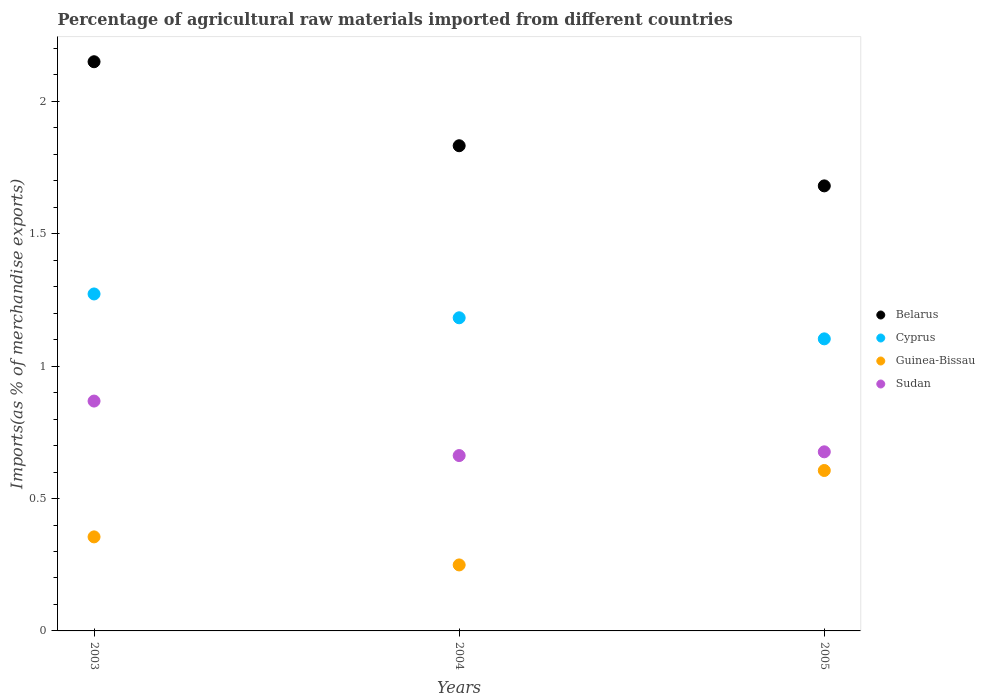Is the number of dotlines equal to the number of legend labels?
Offer a very short reply. Yes. What is the percentage of imports to different countries in Belarus in 2005?
Keep it short and to the point. 1.68. Across all years, what is the maximum percentage of imports to different countries in Sudan?
Offer a very short reply. 0.87. Across all years, what is the minimum percentage of imports to different countries in Sudan?
Your answer should be very brief. 0.66. What is the total percentage of imports to different countries in Belarus in the graph?
Offer a terse response. 5.66. What is the difference between the percentage of imports to different countries in Cyprus in 2003 and that in 2004?
Provide a succinct answer. 0.09. What is the difference between the percentage of imports to different countries in Sudan in 2003 and the percentage of imports to different countries in Guinea-Bissau in 2005?
Ensure brevity in your answer.  0.26. What is the average percentage of imports to different countries in Guinea-Bissau per year?
Give a very brief answer. 0.4. In the year 2004, what is the difference between the percentage of imports to different countries in Belarus and percentage of imports to different countries in Cyprus?
Offer a very short reply. 0.65. In how many years, is the percentage of imports to different countries in Cyprus greater than 0.1 %?
Give a very brief answer. 3. What is the ratio of the percentage of imports to different countries in Sudan in 2004 to that in 2005?
Your answer should be very brief. 0.98. What is the difference between the highest and the second highest percentage of imports to different countries in Guinea-Bissau?
Your answer should be very brief. 0.25. What is the difference between the highest and the lowest percentage of imports to different countries in Cyprus?
Provide a short and direct response. 0.17. In how many years, is the percentage of imports to different countries in Cyprus greater than the average percentage of imports to different countries in Cyprus taken over all years?
Make the answer very short. 1. Is the sum of the percentage of imports to different countries in Sudan in 2003 and 2004 greater than the maximum percentage of imports to different countries in Guinea-Bissau across all years?
Your response must be concise. Yes. Does the percentage of imports to different countries in Sudan monotonically increase over the years?
Offer a terse response. No. How many dotlines are there?
Offer a very short reply. 4. Does the graph contain any zero values?
Give a very brief answer. No. How many legend labels are there?
Give a very brief answer. 4. How are the legend labels stacked?
Offer a very short reply. Vertical. What is the title of the graph?
Offer a very short reply. Percentage of agricultural raw materials imported from different countries. Does "Czech Republic" appear as one of the legend labels in the graph?
Offer a terse response. No. What is the label or title of the X-axis?
Give a very brief answer. Years. What is the label or title of the Y-axis?
Offer a very short reply. Imports(as % of merchandise exports). What is the Imports(as % of merchandise exports) of Belarus in 2003?
Make the answer very short. 2.15. What is the Imports(as % of merchandise exports) of Cyprus in 2003?
Provide a short and direct response. 1.27. What is the Imports(as % of merchandise exports) of Guinea-Bissau in 2003?
Give a very brief answer. 0.36. What is the Imports(as % of merchandise exports) in Sudan in 2003?
Offer a terse response. 0.87. What is the Imports(as % of merchandise exports) in Belarus in 2004?
Give a very brief answer. 1.83. What is the Imports(as % of merchandise exports) in Cyprus in 2004?
Provide a short and direct response. 1.18. What is the Imports(as % of merchandise exports) in Guinea-Bissau in 2004?
Provide a succinct answer. 0.25. What is the Imports(as % of merchandise exports) of Sudan in 2004?
Ensure brevity in your answer.  0.66. What is the Imports(as % of merchandise exports) of Belarus in 2005?
Your response must be concise. 1.68. What is the Imports(as % of merchandise exports) of Cyprus in 2005?
Provide a short and direct response. 1.1. What is the Imports(as % of merchandise exports) in Guinea-Bissau in 2005?
Offer a very short reply. 0.61. What is the Imports(as % of merchandise exports) of Sudan in 2005?
Offer a very short reply. 0.68. Across all years, what is the maximum Imports(as % of merchandise exports) of Belarus?
Provide a short and direct response. 2.15. Across all years, what is the maximum Imports(as % of merchandise exports) in Cyprus?
Your answer should be very brief. 1.27. Across all years, what is the maximum Imports(as % of merchandise exports) in Guinea-Bissau?
Keep it short and to the point. 0.61. Across all years, what is the maximum Imports(as % of merchandise exports) in Sudan?
Provide a short and direct response. 0.87. Across all years, what is the minimum Imports(as % of merchandise exports) in Belarus?
Keep it short and to the point. 1.68. Across all years, what is the minimum Imports(as % of merchandise exports) of Cyprus?
Make the answer very short. 1.1. Across all years, what is the minimum Imports(as % of merchandise exports) in Guinea-Bissau?
Ensure brevity in your answer.  0.25. Across all years, what is the minimum Imports(as % of merchandise exports) of Sudan?
Your response must be concise. 0.66. What is the total Imports(as % of merchandise exports) of Belarus in the graph?
Make the answer very short. 5.66. What is the total Imports(as % of merchandise exports) of Cyprus in the graph?
Keep it short and to the point. 3.56. What is the total Imports(as % of merchandise exports) in Guinea-Bissau in the graph?
Provide a succinct answer. 1.21. What is the total Imports(as % of merchandise exports) of Sudan in the graph?
Your answer should be very brief. 2.21. What is the difference between the Imports(as % of merchandise exports) of Belarus in 2003 and that in 2004?
Give a very brief answer. 0.32. What is the difference between the Imports(as % of merchandise exports) in Cyprus in 2003 and that in 2004?
Offer a terse response. 0.09. What is the difference between the Imports(as % of merchandise exports) in Guinea-Bissau in 2003 and that in 2004?
Your answer should be compact. 0.11. What is the difference between the Imports(as % of merchandise exports) of Sudan in 2003 and that in 2004?
Provide a short and direct response. 0.21. What is the difference between the Imports(as % of merchandise exports) of Belarus in 2003 and that in 2005?
Your answer should be very brief. 0.47. What is the difference between the Imports(as % of merchandise exports) in Cyprus in 2003 and that in 2005?
Offer a very short reply. 0.17. What is the difference between the Imports(as % of merchandise exports) of Guinea-Bissau in 2003 and that in 2005?
Offer a terse response. -0.25. What is the difference between the Imports(as % of merchandise exports) of Sudan in 2003 and that in 2005?
Make the answer very short. 0.19. What is the difference between the Imports(as % of merchandise exports) of Belarus in 2004 and that in 2005?
Your response must be concise. 0.15. What is the difference between the Imports(as % of merchandise exports) of Cyprus in 2004 and that in 2005?
Make the answer very short. 0.08. What is the difference between the Imports(as % of merchandise exports) of Guinea-Bissau in 2004 and that in 2005?
Your answer should be compact. -0.36. What is the difference between the Imports(as % of merchandise exports) in Sudan in 2004 and that in 2005?
Ensure brevity in your answer.  -0.01. What is the difference between the Imports(as % of merchandise exports) in Belarus in 2003 and the Imports(as % of merchandise exports) in Cyprus in 2004?
Ensure brevity in your answer.  0.97. What is the difference between the Imports(as % of merchandise exports) of Belarus in 2003 and the Imports(as % of merchandise exports) of Guinea-Bissau in 2004?
Make the answer very short. 1.9. What is the difference between the Imports(as % of merchandise exports) of Belarus in 2003 and the Imports(as % of merchandise exports) of Sudan in 2004?
Keep it short and to the point. 1.49. What is the difference between the Imports(as % of merchandise exports) of Cyprus in 2003 and the Imports(as % of merchandise exports) of Guinea-Bissau in 2004?
Offer a terse response. 1.02. What is the difference between the Imports(as % of merchandise exports) of Cyprus in 2003 and the Imports(as % of merchandise exports) of Sudan in 2004?
Ensure brevity in your answer.  0.61. What is the difference between the Imports(as % of merchandise exports) in Guinea-Bissau in 2003 and the Imports(as % of merchandise exports) in Sudan in 2004?
Make the answer very short. -0.31. What is the difference between the Imports(as % of merchandise exports) in Belarus in 2003 and the Imports(as % of merchandise exports) in Cyprus in 2005?
Your answer should be compact. 1.05. What is the difference between the Imports(as % of merchandise exports) in Belarus in 2003 and the Imports(as % of merchandise exports) in Guinea-Bissau in 2005?
Give a very brief answer. 1.54. What is the difference between the Imports(as % of merchandise exports) of Belarus in 2003 and the Imports(as % of merchandise exports) of Sudan in 2005?
Give a very brief answer. 1.47. What is the difference between the Imports(as % of merchandise exports) of Cyprus in 2003 and the Imports(as % of merchandise exports) of Guinea-Bissau in 2005?
Provide a short and direct response. 0.67. What is the difference between the Imports(as % of merchandise exports) of Cyprus in 2003 and the Imports(as % of merchandise exports) of Sudan in 2005?
Offer a very short reply. 0.6. What is the difference between the Imports(as % of merchandise exports) of Guinea-Bissau in 2003 and the Imports(as % of merchandise exports) of Sudan in 2005?
Offer a very short reply. -0.32. What is the difference between the Imports(as % of merchandise exports) of Belarus in 2004 and the Imports(as % of merchandise exports) of Cyprus in 2005?
Make the answer very short. 0.73. What is the difference between the Imports(as % of merchandise exports) in Belarus in 2004 and the Imports(as % of merchandise exports) in Guinea-Bissau in 2005?
Your answer should be very brief. 1.23. What is the difference between the Imports(as % of merchandise exports) of Belarus in 2004 and the Imports(as % of merchandise exports) of Sudan in 2005?
Ensure brevity in your answer.  1.16. What is the difference between the Imports(as % of merchandise exports) in Cyprus in 2004 and the Imports(as % of merchandise exports) in Guinea-Bissau in 2005?
Your answer should be very brief. 0.58. What is the difference between the Imports(as % of merchandise exports) in Cyprus in 2004 and the Imports(as % of merchandise exports) in Sudan in 2005?
Your answer should be very brief. 0.51. What is the difference between the Imports(as % of merchandise exports) in Guinea-Bissau in 2004 and the Imports(as % of merchandise exports) in Sudan in 2005?
Offer a terse response. -0.43. What is the average Imports(as % of merchandise exports) of Belarus per year?
Ensure brevity in your answer.  1.89. What is the average Imports(as % of merchandise exports) in Cyprus per year?
Your answer should be very brief. 1.19. What is the average Imports(as % of merchandise exports) of Guinea-Bissau per year?
Offer a terse response. 0.4. What is the average Imports(as % of merchandise exports) in Sudan per year?
Keep it short and to the point. 0.74. In the year 2003, what is the difference between the Imports(as % of merchandise exports) in Belarus and Imports(as % of merchandise exports) in Cyprus?
Offer a terse response. 0.88. In the year 2003, what is the difference between the Imports(as % of merchandise exports) in Belarus and Imports(as % of merchandise exports) in Guinea-Bissau?
Provide a succinct answer. 1.79. In the year 2003, what is the difference between the Imports(as % of merchandise exports) of Belarus and Imports(as % of merchandise exports) of Sudan?
Provide a succinct answer. 1.28. In the year 2003, what is the difference between the Imports(as % of merchandise exports) in Cyprus and Imports(as % of merchandise exports) in Guinea-Bissau?
Keep it short and to the point. 0.92. In the year 2003, what is the difference between the Imports(as % of merchandise exports) in Cyprus and Imports(as % of merchandise exports) in Sudan?
Give a very brief answer. 0.4. In the year 2003, what is the difference between the Imports(as % of merchandise exports) in Guinea-Bissau and Imports(as % of merchandise exports) in Sudan?
Provide a succinct answer. -0.51. In the year 2004, what is the difference between the Imports(as % of merchandise exports) of Belarus and Imports(as % of merchandise exports) of Cyprus?
Ensure brevity in your answer.  0.65. In the year 2004, what is the difference between the Imports(as % of merchandise exports) of Belarus and Imports(as % of merchandise exports) of Guinea-Bissau?
Offer a very short reply. 1.58. In the year 2004, what is the difference between the Imports(as % of merchandise exports) of Belarus and Imports(as % of merchandise exports) of Sudan?
Your answer should be compact. 1.17. In the year 2004, what is the difference between the Imports(as % of merchandise exports) in Cyprus and Imports(as % of merchandise exports) in Guinea-Bissau?
Your answer should be compact. 0.93. In the year 2004, what is the difference between the Imports(as % of merchandise exports) of Cyprus and Imports(as % of merchandise exports) of Sudan?
Offer a very short reply. 0.52. In the year 2004, what is the difference between the Imports(as % of merchandise exports) of Guinea-Bissau and Imports(as % of merchandise exports) of Sudan?
Keep it short and to the point. -0.41. In the year 2005, what is the difference between the Imports(as % of merchandise exports) in Belarus and Imports(as % of merchandise exports) in Cyprus?
Your response must be concise. 0.58. In the year 2005, what is the difference between the Imports(as % of merchandise exports) of Belarus and Imports(as % of merchandise exports) of Guinea-Bissau?
Offer a terse response. 1.07. In the year 2005, what is the difference between the Imports(as % of merchandise exports) in Belarus and Imports(as % of merchandise exports) in Sudan?
Your answer should be compact. 1. In the year 2005, what is the difference between the Imports(as % of merchandise exports) in Cyprus and Imports(as % of merchandise exports) in Guinea-Bissau?
Give a very brief answer. 0.5. In the year 2005, what is the difference between the Imports(as % of merchandise exports) in Cyprus and Imports(as % of merchandise exports) in Sudan?
Provide a succinct answer. 0.43. In the year 2005, what is the difference between the Imports(as % of merchandise exports) in Guinea-Bissau and Imports(as % of merchandise exports) in Sudan?
Give a very brief answer. -0.07. What is the ratio of the Imports(as % of merchandise exports) in Belarus in 2003 to that in 2004?
Your response must be concise. 1.17. What is the ratio of the Imports(as % of merchandise exports) of Cyprus in 2003 to that in 2004?
Make the answer very short. 1.08. What is the ratio of the Imports(as % of merchandise exports) of Guinea-Bissau in 2003 to that in 2004?
Keep it short and to the point. 1.43. What is the ratio of the Imports(as % of merchandise exports) in Sudan in 2003 to that in 2004?
Make the answer very short. 1.31. What is the ratio of the Imports(as % of merchandise exports) in Belarus in 2003 to that in 2005?
Make the answer very short. 1.28. What is the ratio of the Imports(as % of merchandise exports) of Cyprus in 2003 to that in 2005?
Provide a succinct answer. 1.15. What is the ratio of the Imports(as % of merchandise exports) of Guinea-Bissau in 2003 to that in 2005?
Make the answer very short. 0.59. What is the ratio of the Imports(as % of merchandise exports) in Sudan in 2003 to that in 2005?
Keep it short and to the point. 1.28. What is the ratio of the Imports(as % of merchandise exports) of Belarus in 2004 to that in 2005?
Provide a succinct answer. 1.09. What is the ratio of the Imports(as % of merchandise exports) in Cyprus in 2004 to that in 2005?
Your answer should be very brief. 1.07. What is the ratio of the Imports(as % of merchandise exports) in Guinea-Bissau in 2004 to that in 2005?
Make the answer very short. 0.41. What is the ratio of the Imports(as % of merchandise exports) in Sudan in 2004 to that in 2005?
Your answer should be compact. 0.98. What is the difference between the highest and the second highest Imports(as % of merchandise exports) of Belarus?
Your answer should be compact. 0.32. What is the difference between the highest and the second highest Imports(as % of merchandise exports) of Cyprus?
Provide a short and direct response. 0.09. What is the difference between the highest and the second highest Imports(as % of merchandise exports) in Guinea-Bissau?
Give a very brief answer. 0.25. What is the difference between the highest and the second highest Imports(as % of merchandise exports) of Sudan?
Provide a succinct answer. 0.19. What is the difference between the highest and the lowest Imports(as % of merchandise exports) in Belarus?
Your answer should be compact. 0.47. What is the difference between the highest and the lowest Imports(as % of merchandise exports) of Cyprus?
Your answer should be compact. 0.17. What is the difference between the highest and the lowest Imports(as % of merchandise exports) of Guinea-Bissau?
Offer a very short reply. 0.36. What is the difference between the highest and the lowest Imports(as % of merchandise exports) of Sudan?
Make the answer very short. 0.21. 